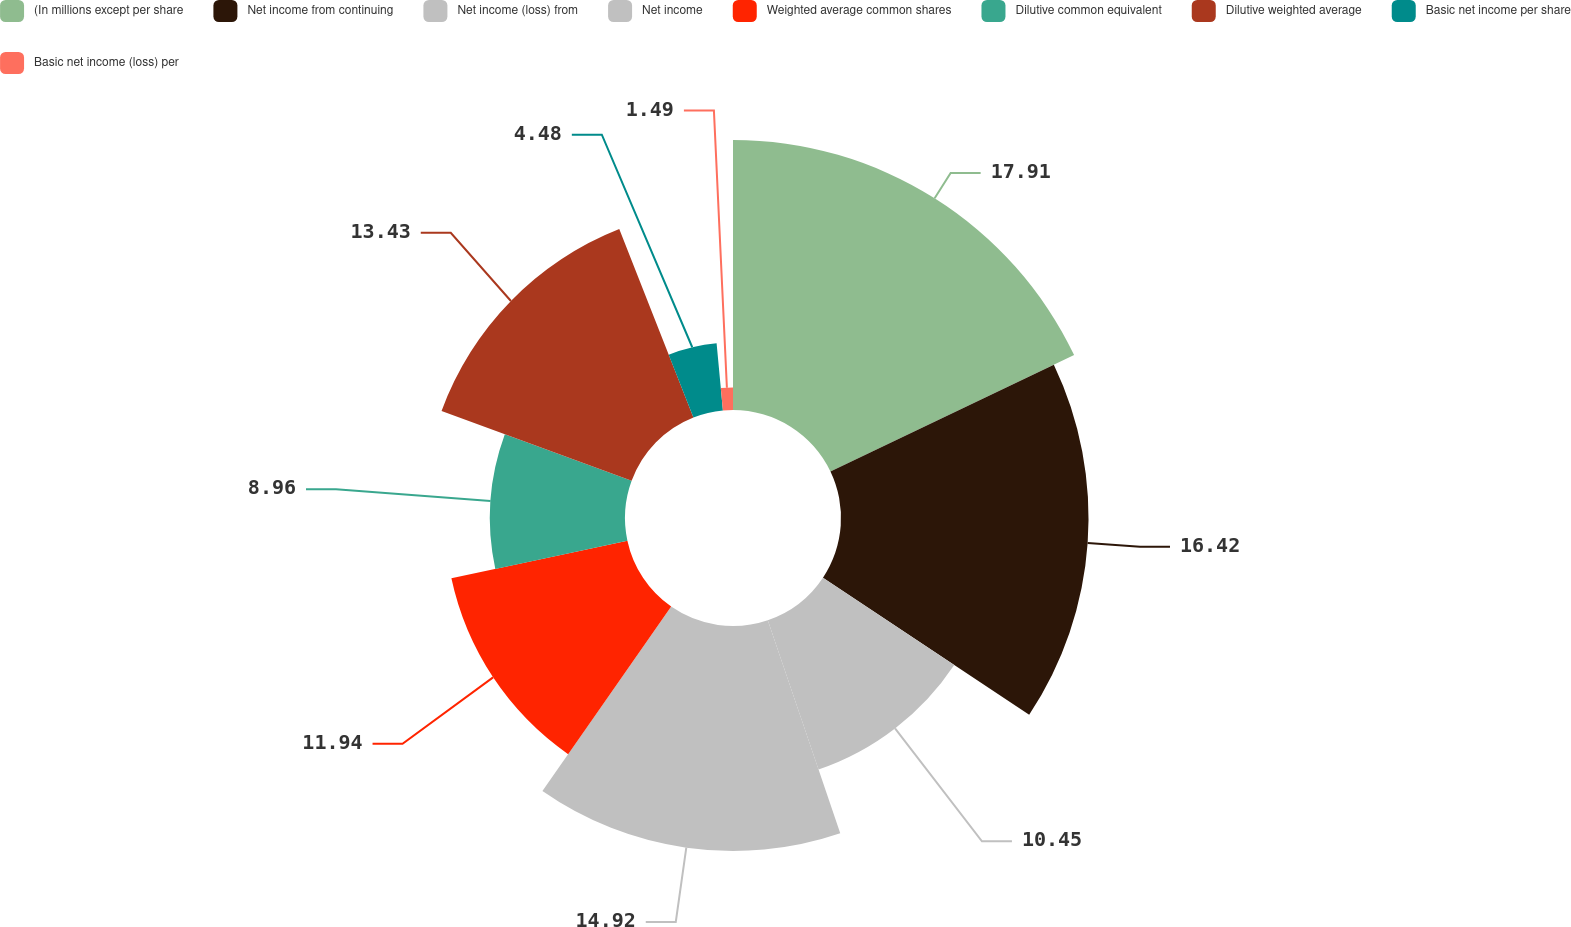Convert chart. <chart><loc_0><loc_0><loc_500><loc_500><pie_chart><fcel>(In millions except per share<fcel>Net income from continuing<fcel>Net income (loss) from<fcel>Net income<fcel>Weighted average common shares<fcel>Dilutive common equivalent<fcel>Dilutive weighted average<fcel>Basic net income per share<fcel>Basic net income (loss) per<nl><fcel>17.91%<fcel>16.42%<fcel>10.45%<fcel>14.92%<fcel>11.94%<fcel>8.96%<fcel>13.43%<fcel>4.48%<fcel>1.49%<nl></chart> 